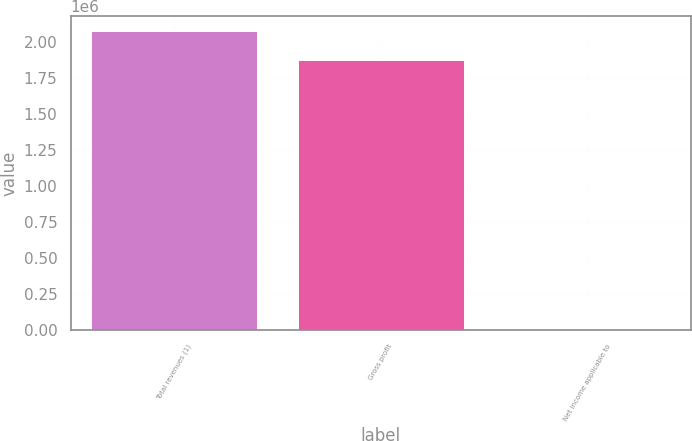<chart> <loc_0><loc_0><loc_500><loc_500><bar_chart><fcel>Total revenues (1)<fcel>Gross profit<fcel>Net income applicable to<nl><fcel>2.07938e+06<fcel>1.87938e+06<fcel>10<nl></chart> 